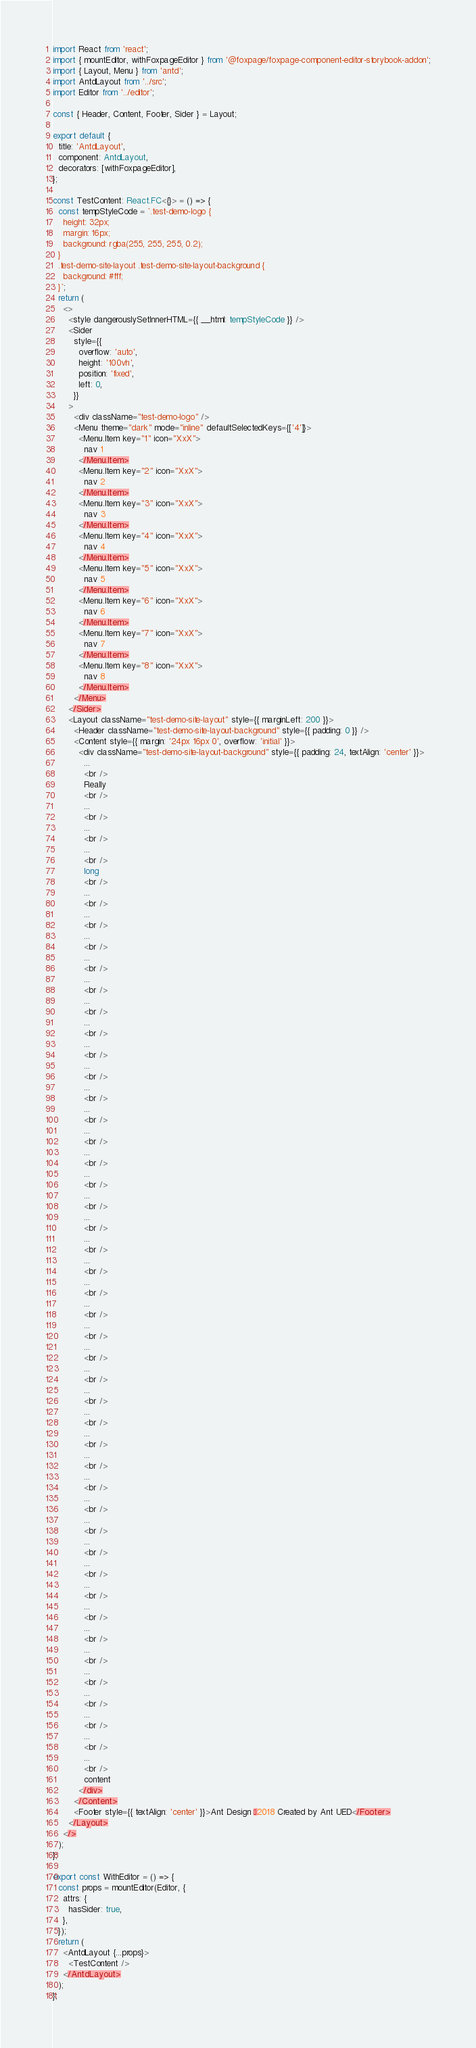<code> <loc_0><loc_0><loc_500><loc_500><_TypeScript_>import React from 'react';
import { mountEditor, withFoxpageEditor } from '@foxpage/foxpage-component-editor-storybook-addon';
import { Layout, Menu } from 'antd';
import AntdLayout from '../src';
import Editor from '../editor';

const { Header, Content, Footer, Sider } = Layout;

export default {
  title: 'AntdLayout',
  component: AntdLayout,
  decorators: [withFoxpageEditor],
};

const TestContent: React.FC<{}> = () => {
  const tempStyleCode = `.test-demo-logo {
    height: 32px;
    margin: 16px;
    background: rgba(255, 255, 255, 0.2);
  }
  .test-demo-site-layout .test-demo-site-layout-background {
    background: #fff;
  }`;
  return (
    <>
      <style dangerouslySetInnerHTML={{ __html: tempStyleCode }} />
      <Sider
        style={{
          overflow: 'auto',
          height: '100vh',
          position: 'fixed',
          left: 0,
        }}
      >
        <div className="test-demo-logo" />
        <Menu theme="dark" mode="inline" defaultSelectedKeys={['4']}>
          <Menu.Item key="1" icon="XxX">
            nav 1
          </Menu.Item>
          <Menu.Item key="2" icon="XxX">
            nav 2
          </Menu.Item>
          <Menu.Item key="3" icon="XxX">
            nav 3
          </Menu.Item>
          <Menu.Item key="4" icon="XxX">
            nav 4
          </Menu.Item>
          <Menu.Item key="5" icon="XxX">
            nav 5
          </Menu.Item>
          <Menu.Item key="6" icon="XxX">
            nav 6
          </Menu.Item>
          <Menu.Item key="7" icon="XxX">
            nav 7
          </Menu.Item>
          <Menu.Item key="8" icon="XxX">
            nav 8
          </Menu.Item>
        </Menu>
      </Sider>
      <Layout className="test-demo-site-layout" style={{ marginLeft: 200 }}>
        <Header className="test-demo-site-layout-background" style={{ padding: 0 }} />
        <Content style={{ margin: '24px 16px 0', overflow: 'initial' }}>
          <div className="test-demo-site-layout-background" style={{ padding: 24, textAlign: 'center' }}>
            ...
            <br />
            Really
            <br />
            ...
            <br />
            ...
            <br />
            ...
            <br />
            long
            <br />
            ...
            <br />
            ...
            <br />
            ...
            <br />
            ...
            <br />
            ...
            <br />
            ...
            <br />
            ...
            <br />
            ...
            <br />
            ...
            <br />
            ...
            <br />
            ...
            <br />
            ...
            <br />
            ...
            <br />
            ...
            <br />
            ...
            <br />
            ...
            <br />
            ...
            <br />
            ...
            <br />
            ...
            <br />
            ...
            <br />
            ...
            <br />
            ...
            <br />
            ...
            <br />
            ...
            <br />
            ...
            <br />
            ...
            <br />
            ...
            <br />
            ...
            <br />
            ...
            <br />
            ...
            <br />
            ...
            <br />
            ...
            <br />
            ...
            <br />
            ...
            <br />
            ...
            <br />
            ...
            <br />
            ...
            <br />
            ...
            <br />
            ...
            <br />
            ...
            <br />
            ...
            <br />
            content
          </div>
        </Content>
        <Footer style={{ textAlign: 'center' }}>Ant Design ©2018 Created by Ant UED</Footer>
      </Layout>
    </>
  );
};

export const WithEditor = () => {
  const props = mountEditor(Editor, {
    attrs: {
      hasSider: true,
    },
  });
  return (
    <AntdLayout {...props}>
      <TestContent />
    </AntdLayout>
  );
};
</code> 